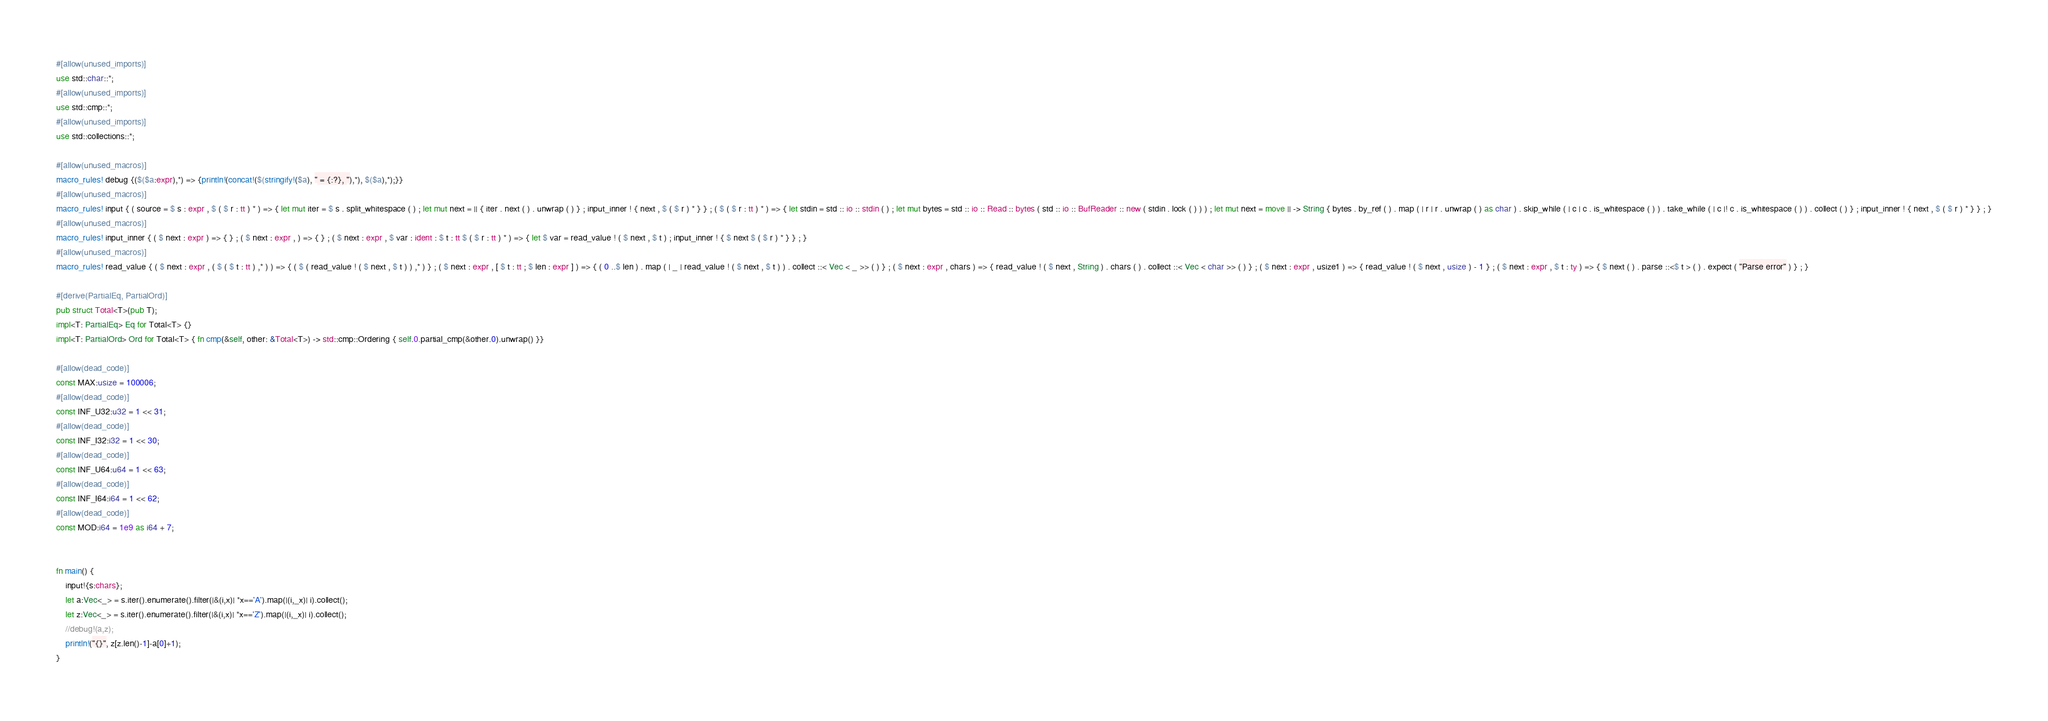<code> <loc_0><loc_0><loc_500><loc_500><_Rust_>#[allow(unused_imports)]
use std::char::*;
#[allow(unused_imports)]
use std::cmp::*;
#[allow(unused_imports)]
use std::collections::*;

#[allow(unused_macros)]
macro_rules! debug {($($a:expr),*) => {println!(concat!($(stringify!($a), " = {:?}, "),*), $($a),*);}}
#[allow(unused_macros)]
macro_rules! input { ( source = $ s : expr , $ ( $ r : tt ) * ) => { let mut iter = $ s . split_whitespace ( ) ; let mut next = || { iter . next ( ) . unwrap ( ) } ; input_inner ! { next , $ ( $ r ) * } } ; ( $ ( $ r : tt ) * ) => { let stdin = std :: io :: stdin ( ) ; let mut bytes = std :: io :: Read :: bytes ( std :: io :: BufReader :: new ( stdin . lock ( ) ) ) ; let mut next = move || -> String { bytes . by_ref ( ) . map ( | r | r . unwrap ( ) as char ) . skip_while ( | c | c . is_whitespace ( ) ) . take_while ( | c |! c . is_whitespace ( ) ) . collect ( ) } ; input_inner ! { next , $ ( $ r ) * } } ; }
#[allow(unused_macros)]
macro_rules! input_inner { ( $ next : expr ) => { } ; ( $ next : expr , ) => { } ; ( $ next : expr , $ var : ident : $ t : tt $ ( $ r : tt ) * ) => { let $ var = read_value ! ( $ next , $ t ) ; input_inner ! { $ next $ ( $ r ) * } } ; }
#[allow(unused_macros)]
macro_rules! read_value { ( $ next : expr , ( $ ( $ t : tt ) ,* ) ) => { ( $ ( read_value ! ( $ next , $ t ) ) ,* ) } ; ( $ next : expr , [ $ t : tt ; $ len : expr ] ) => { ( 0 ..$ len ) . map ( | _ | read_value ! ( $ next , $ t ) ) . collect ::< Vec < _ >> ( ) } ; ( $ next : expr , chars ) => { read_value ! ( $ next , String ) . chars ( ) . collect ::< Vec < char >> ( ) } ; ( $ next : expr , usize1 ) => { read_value ! ( $ next , usize ) - 1 } ; ( $ next : expr , $ t : ty ) => { $ next ( ) . parse ::<$ t > ( ) . expect ( "Parse error" ) } ; }

#[derive(PartialEq, PartialOrd)]
pub struct Total<T>(pub T);
impl<T: PartialEq> Eq for Total<T> {}
impl<T: PartialOrd> Ord for Total<T> { fn cmp(&self, other: &Total<T>) -> std::cmp::Ordering { self.0.partial_cmp(&other.0).unwrap() }}

#[allow(dead_code)]
const MAX:usize = 100006;
#[allow(dead_code)]
const INF_U32:u32 = 1 << 31;
#[allow(dead_code)]
const INF_I32:i32 = 1 << 30;
#[allow(dead_code)]
const INF_U64:u64 = 1 << 63;
#[allow(dead_code)]
const INF_I64:i64 = 1 << 62;
#[allow(dead_code)]
const MOD:i64 = 1e9 as i64 + 7;


fn main() {
    input!{s:chars};
    let a:Vec<_> = s.iter().enumerate().filter(|&(i,x)| *x=='A').map(|(i,_x)| i).collect();
    let z:Vec<_> = s.iter().enumerate().filter(|&(i,x)| *x=='Z').map(|(i,_x)| i).collect();
    //debug!(a,z);
    println!("{}", z[z.len()-1]-a[0]+1);
}
</code> 